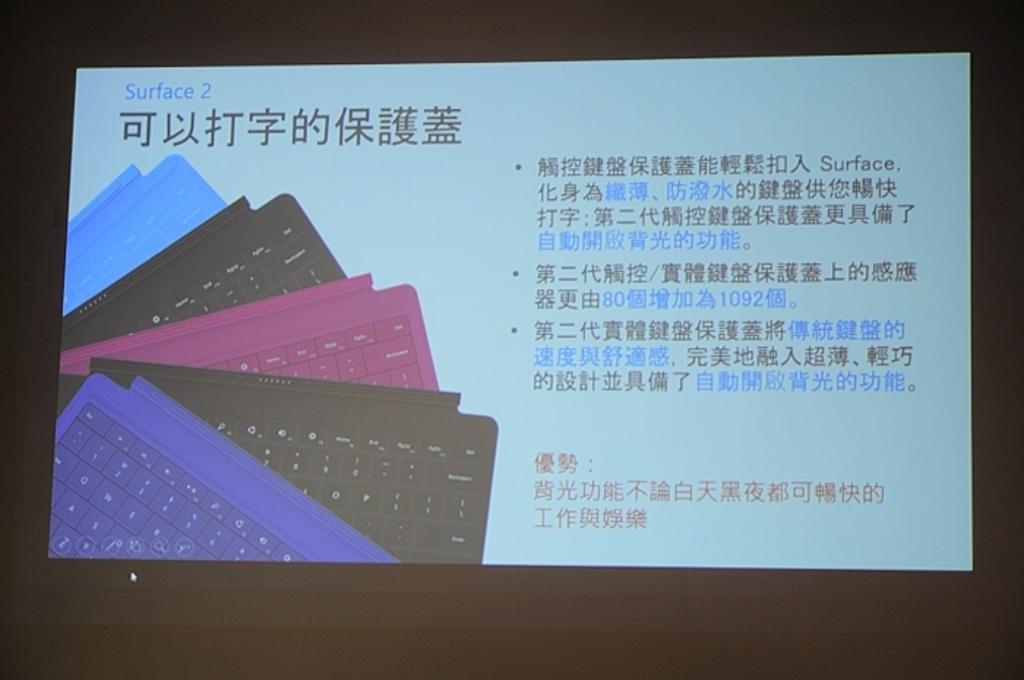Provide a one-sentence caption for the provided image. a screen that has different colored keyboards on it and the words 'surface 2' on the top left corner. 